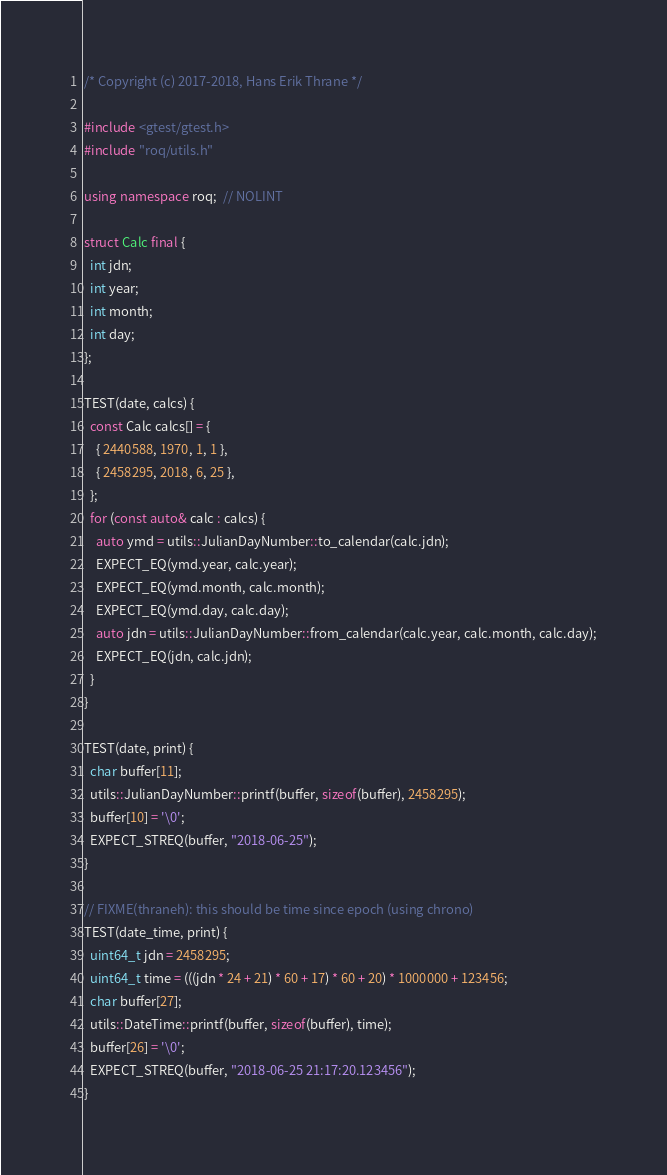Convert code to text. <code><loc_0><loc_0><loc_500><loc_500><_C++_>/* Copyright (c) 2017-2018, Hans Erik Thrane */

#include <gtest/gtest.h>
#include "roq/utils.h"

using namespace roq;  // NOLINT

struct Calc final {
  int jdn;
  int year;
  int month;
  int day;
};

TEST(date, calcs) {
  const Calc calcs[] = {
    { 2440588, 1970, 1, 1 },
    { 2458295, 2018, 6, 25 },
  };
  for (const auto& calc : calcs) {
    auto ymd = utils::JulianDayNumber::to_calendar(calc.jdn);
    EXPECT_EQ(ymd.year, calc.year);
    EXPECT_EQ(ymd.month, calc.month);
    EXPECT_EQ(ymd.day, calc.day);
    auto jdn = utils::JulianDayNumber::from_calendar(calc.year, calc.month, calc.day);
    EXPECT_EQ(jdn, calc.jdn);
  }
}

TEST(date, print) {
  char buffer[11];
  utils::JulianDayNumber::printf(buffer, sizeof(buffer), 2458295);
  buffer[10] = '\0';
  EXPECT_STREQ(buffer, "2018-06-25");
}

// FIXME(thraneh): this should be time since epoch (using chrono)
TEST(date_time, print) {
  uint64_t jdn = 2458295;
  uint64_t time = (((jdn * 24 + 21) * 60 + 17) * 60 + 20) * 1000000 + 123456;
  char buffer[27];
  utils::DateTime::printf(buffer, sizeof(buffer), time);
  buffer[26] = '\0';
  EXPECT_STREQ(buffer, "2018-06-25 21:17:20.123456");
}
</code> 